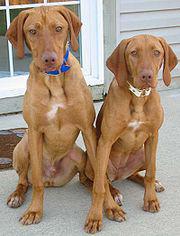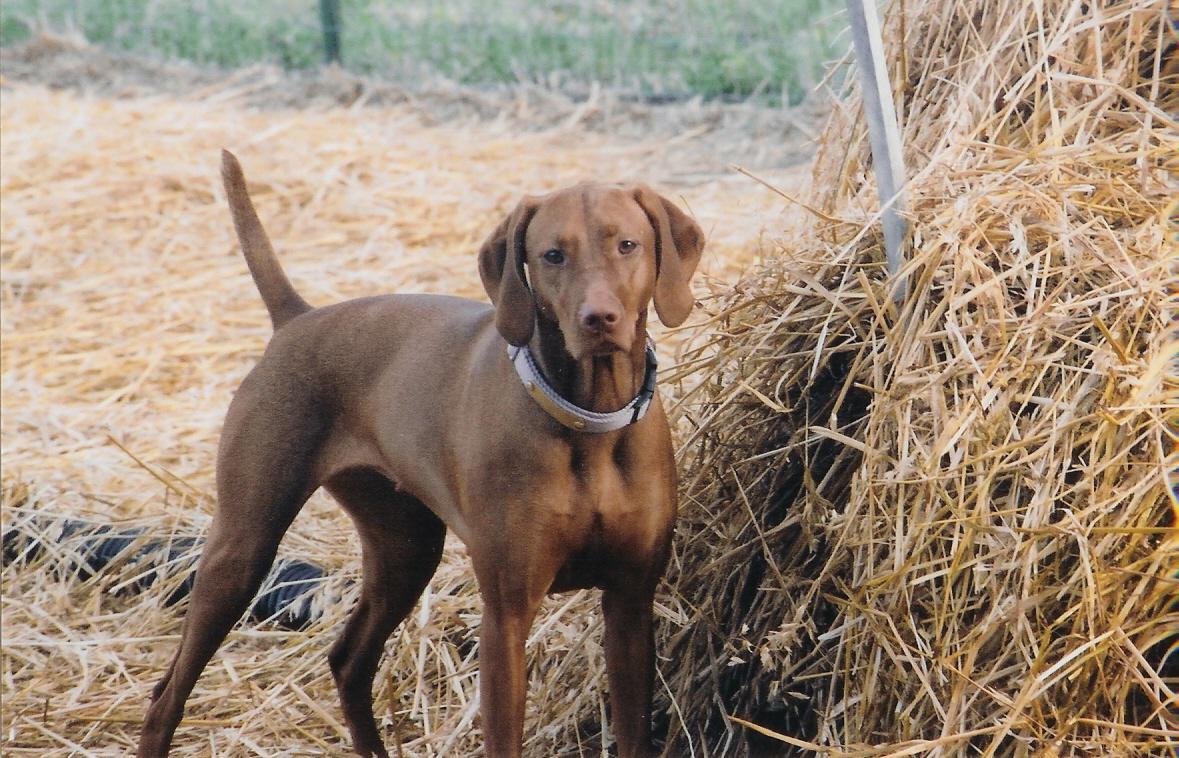The first image is the image on the left, the second image is the image on the right. Analyze the images presented: Is the assertion "One image shows two dogs with the same coloring sitting side-by-side with their chests facing the camera, and the other image shows one dog in a standing pose outdoors." valid? Answer yes or no. Yes. The first image is the image on the left, the second image is the image on the right. Analyze the images presented: Is the assertion "The left image contains exactly two dogs." valid? Answer yes or no. Yes. 